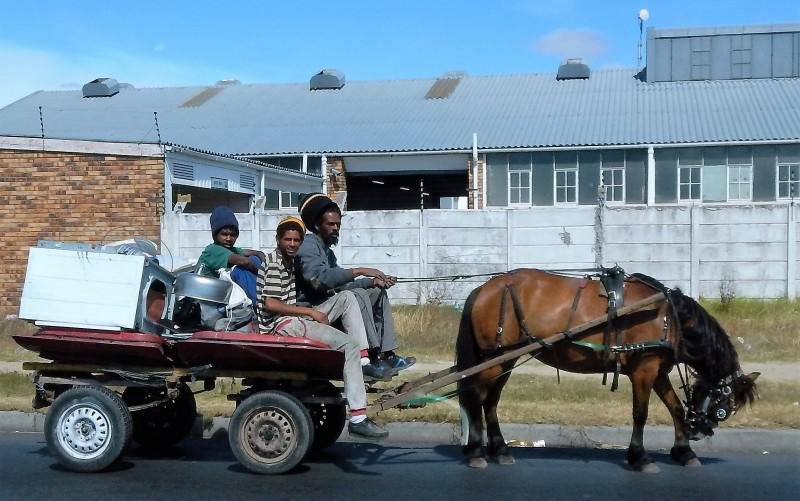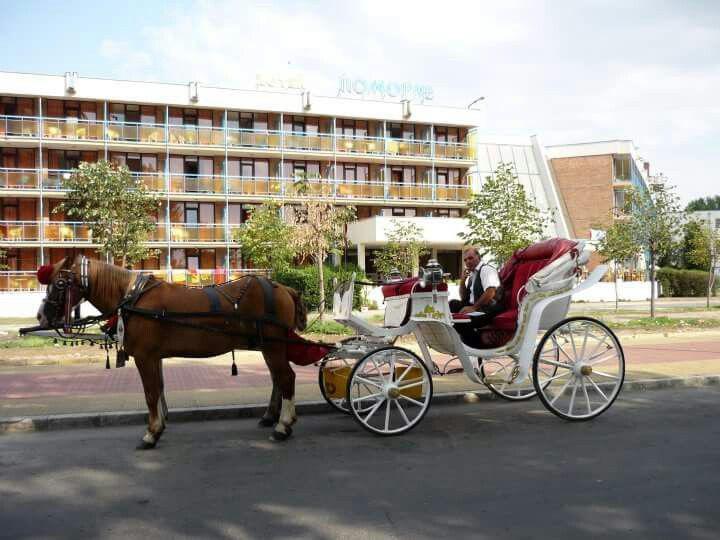The first image is the image on the left, the second image is the image on the right. Analyze the images presented: Is the assertion "the right side pics has a four wheel wagon moving to the right" valid? Answer yes or no. No. The first image is the image on the left, the second image is the image on the right. For the images displayed, is the sentence "There are no less than three animals pulling something on wheels." factually correct? Answer yes or no. No. 